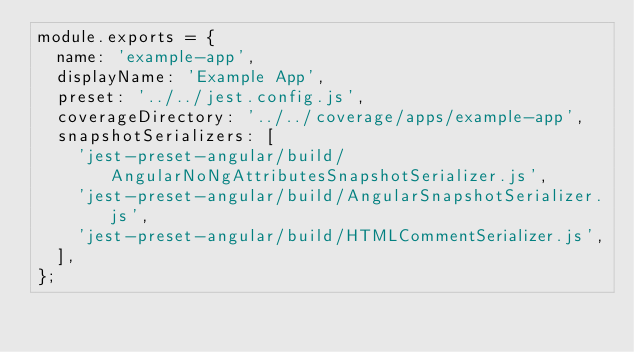Convert code to text. <code><loc_0><loc_0><loc_500><loc_500><_JavaScript_>module.exports = {
  name: 'example-app',
  displayName: 'Example App',
  preset: '../../jest.config.js',
  coverageDirectory: '../../coverage/apps/example-app',
  snapshotSerializers: [
    'jest-preset-angular/build/AngularNoNgAttributesSnapshotSerializer.js',
    'jest-preset-angular/build/AngularSnapshotSerializer.js',
    'jest-preset-angular/build/HTMLCommentSerializer.js',
  ],
};
</code> 